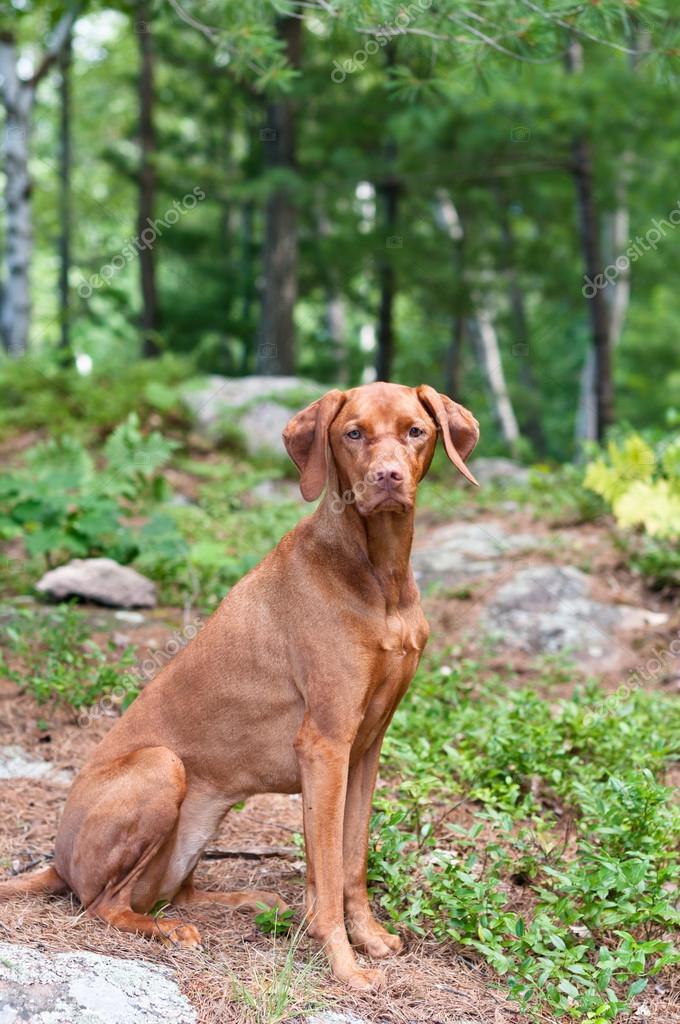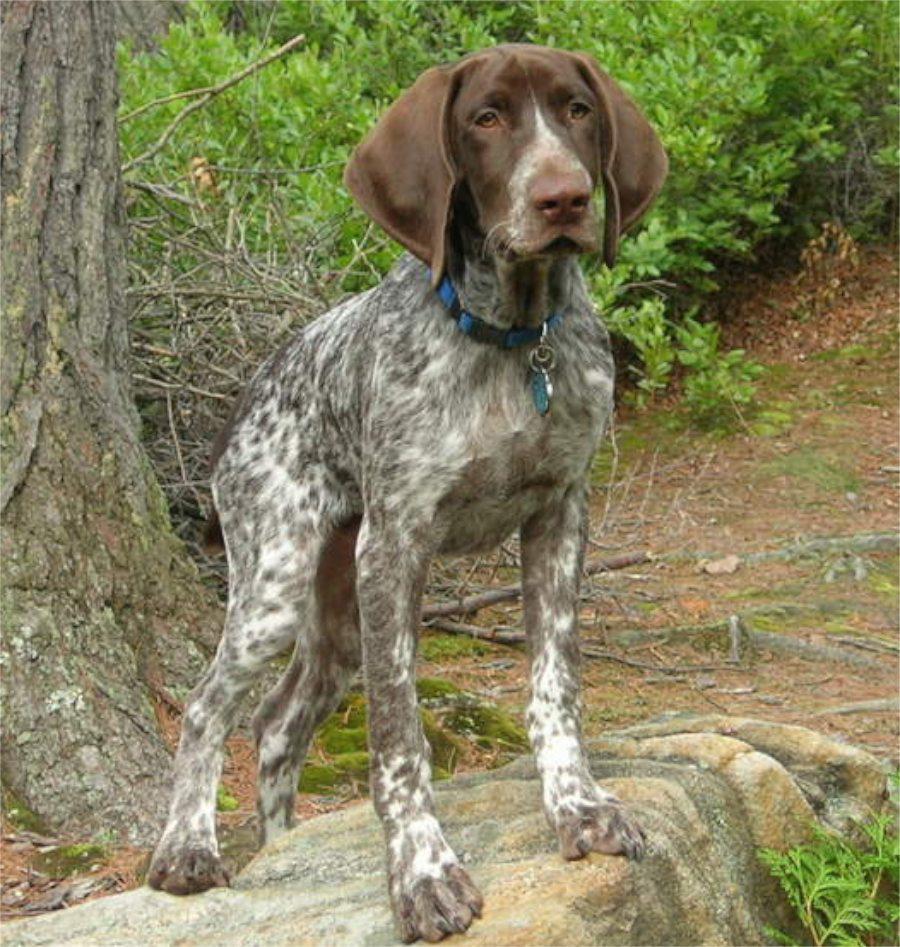The first image is the image on the left, the second image is the image on the right. Considering the images on both sides, is "In one of the images, there is a brown dog that is lying in the grass." valid? Answer yes or no. No. 